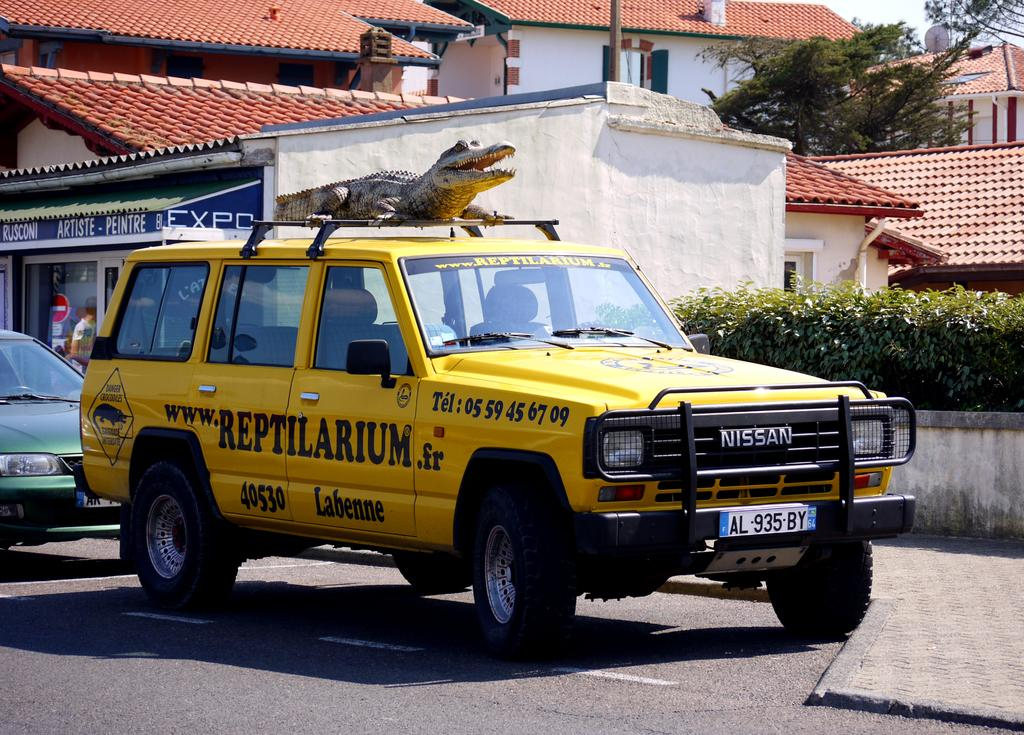<image>
Share a concise interpretation of the image provided. A yellow Nissan SUV says Reptilarium on the side. 